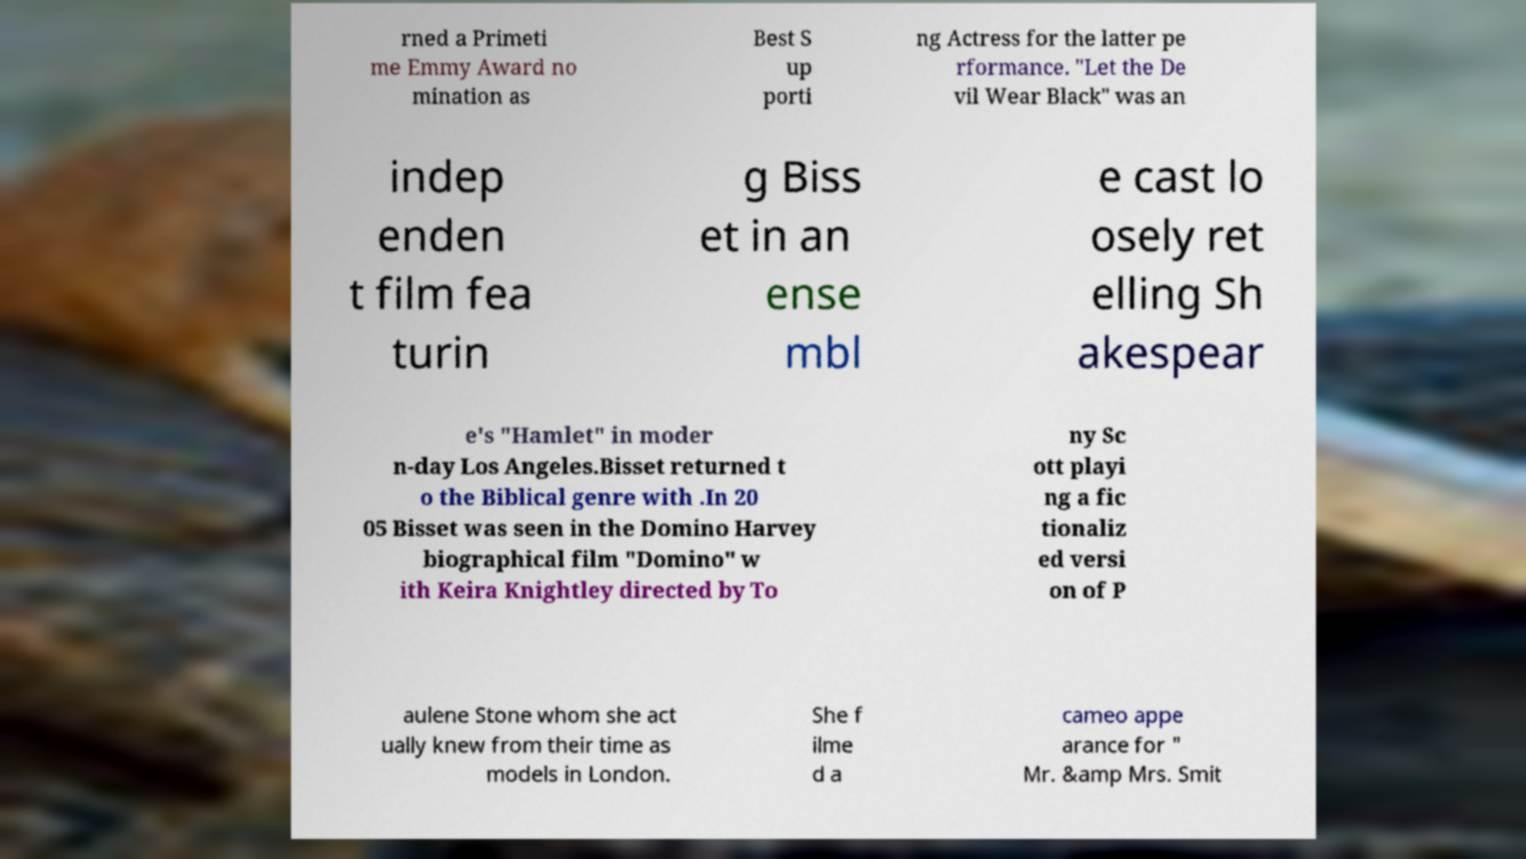I need the written content from this picture converted into text. Can you do that? rned a Primeti me Emmy Award no mination as Best S up porti ng Actress for the latter pe rformance. "Let the De vil Wear Black" was an indep enden t film fea turin g Biss et in an ense mbl e cast lo osely ret elling Sh akespear e's "Hamlet" in moder n-day Los Angeles.Bisset returned t o the Biblical genre with .In 20 05 Bisset was seen in the Domino Harvey biographical film "Domino" w ith Keira Knightley directed by To ny Sc ott playi ng a fic tionaliz ed versi on of P aulene Stone whom she act ually knew from their time as models in London. She f ilme d a cameo appe arance for " Mr. &amp Mrs. Smit 